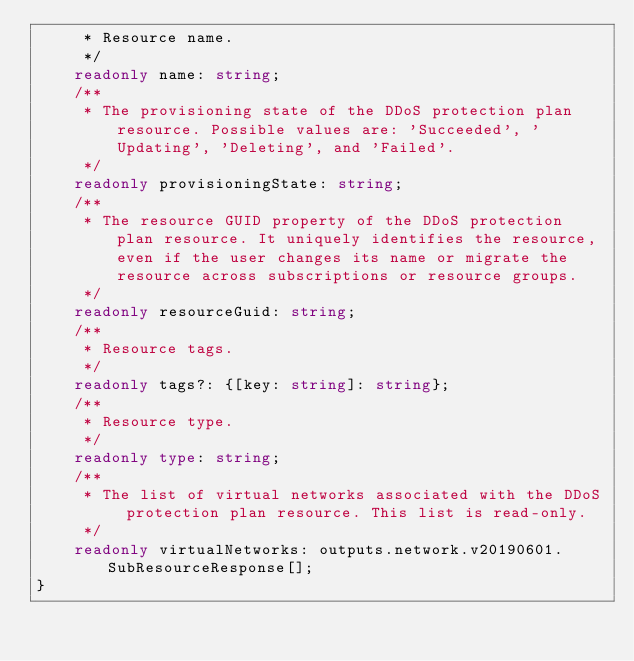<code> <loc_0><loc_0><loc_500><loc_500><_TypeScript_>     * Resource name.
     */
    readonly name: string;
    /**
     * The provisioning state of the DDoS protection plan resource. Possible values are: 'Succeeded', 'Updating', 'Deleting', and 'Failed'.
     */
    readonly provisioningState: string;
    /**
     * The resource GUID property of the DDoS protection plan resource. It uniquely identifies the resource, even if the user changes its name or migrate the resource across subscriptions or resource groups.
     */
    readonly resourceGuid: string;
    /**
     * Resource tags.
     */
    readonly tags?: {[key: string]: string};
    /**
     * Resource type.
     */
    readonly type: string;
    /**
     * The list of virtual networks associated with the DDoS protection plan resource. This list is read-only.
     */
    readonly virtualNetworks: outputs.network.v20190601.SubResourceResponse[];
}
</code> 